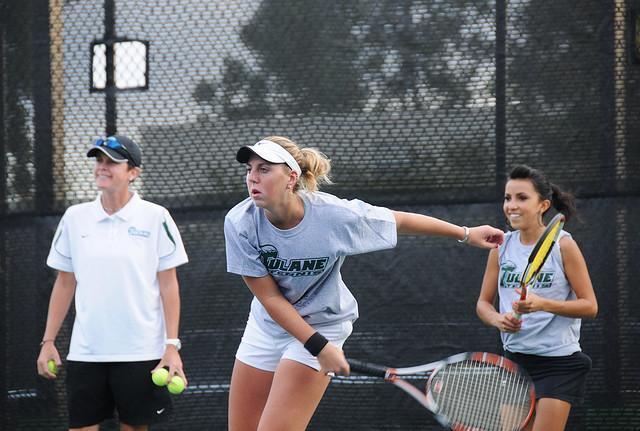How many balls are there?
Give a very brief answer. 3. How many people are wearing a cap?
Give a very brief answer. 2. How many people are in the picture?
Give a very brief answer. 3. How many horses are to the left of the light pole?
Give a very brief answer. 0. 